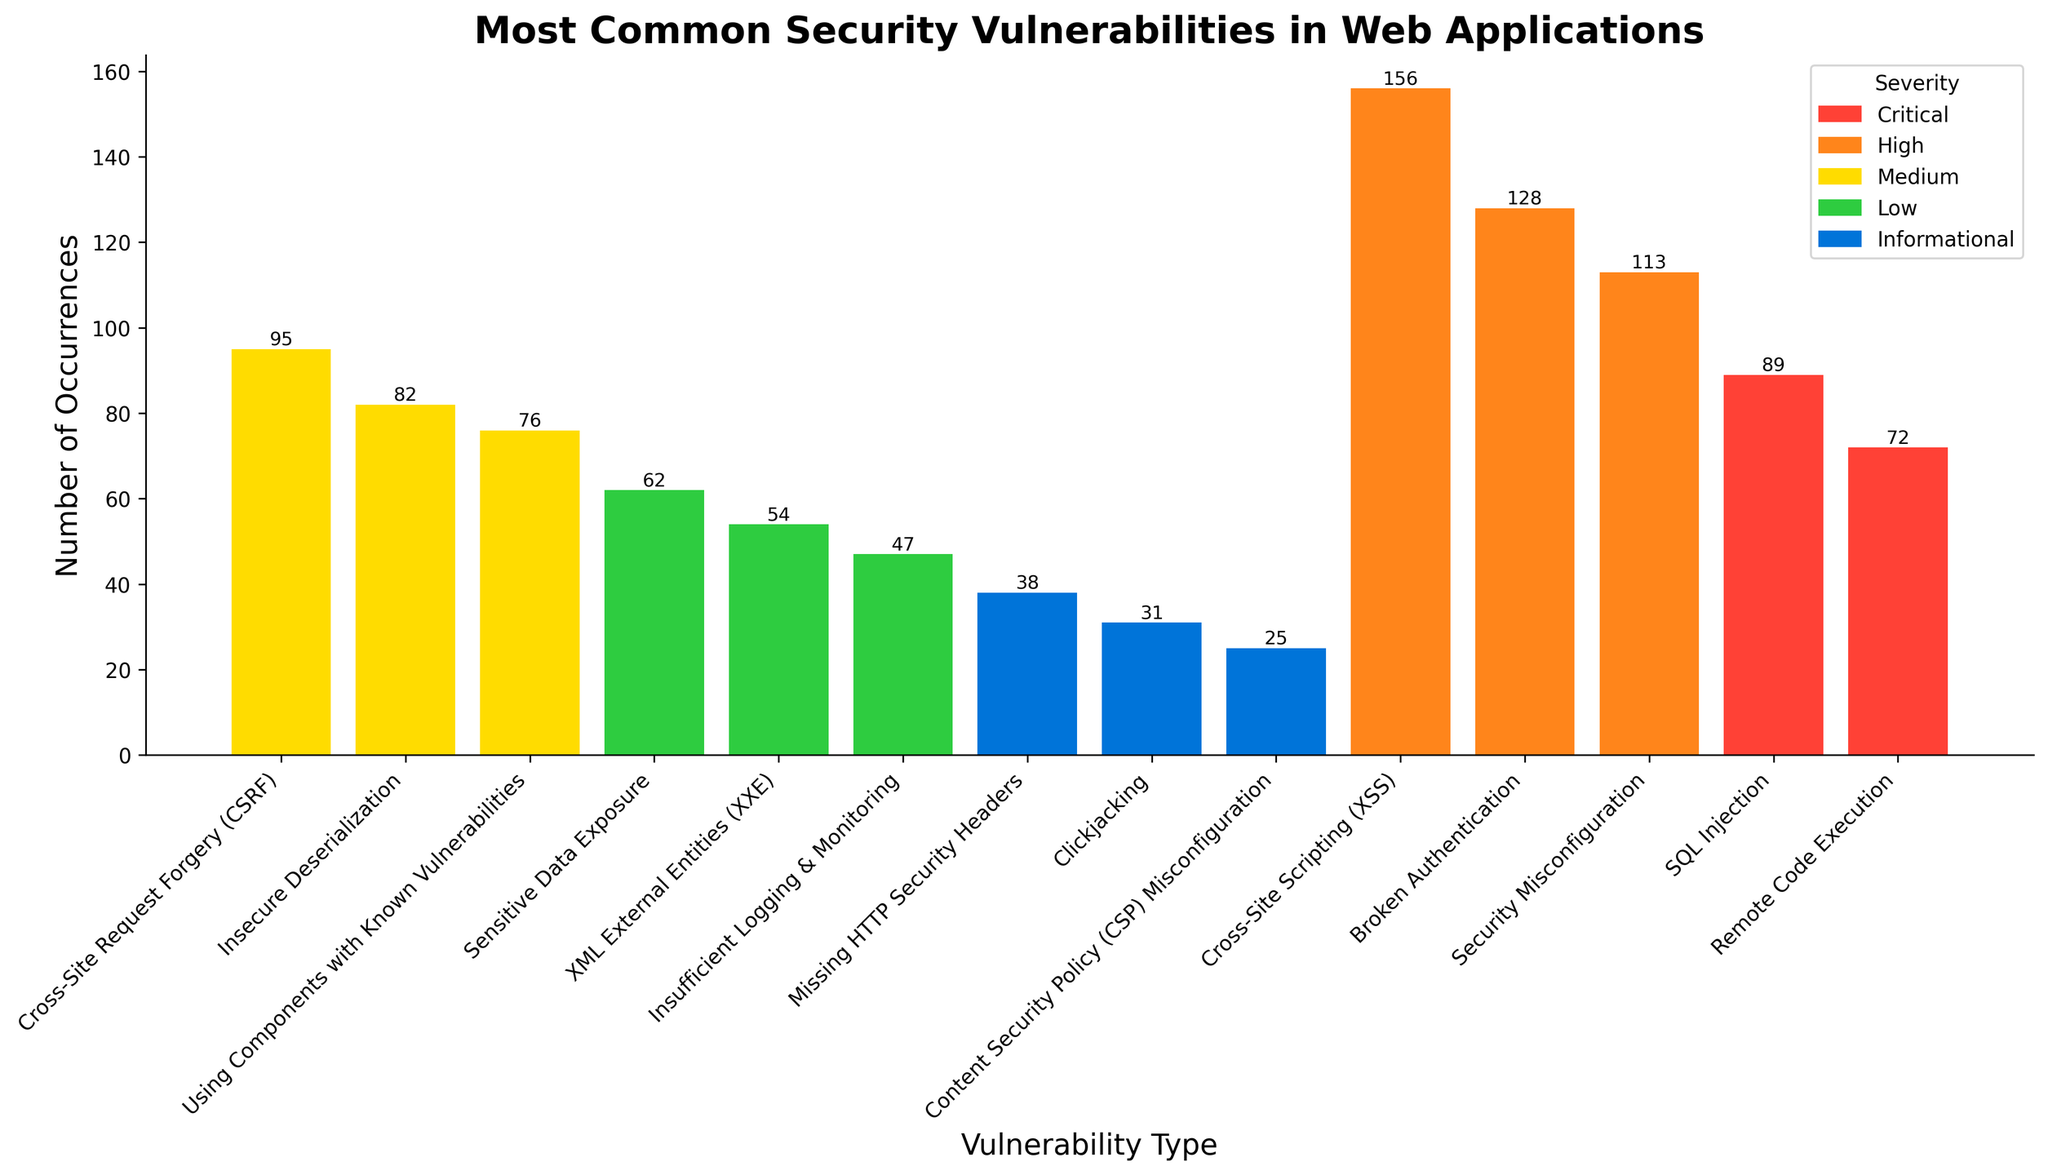Which vulnerability has the highest number of occurrences? The tallest bar in the figure corresponds to the vulnerability with the highest number of occurrences. This bar represents "Cross-Site Scripting (XSS)" with 156 occurrences.
Answer: Cross-Site Scripting (XSS) Which severity level has the fewest total occurrences? To determine the severity level with the fewest occurrences, sum the number of occurrences of vulnerabilities within each severity and compare. The "Informational" severity with 38 + 31 + 25 = 94 occurrences has the fewest.
Answer: Informational What is the combined total of occurrences for "Critical" severity vulnerabilities? Add the occurrences of all vulnerabilities listed under "Critical" severity: 89 (SQL Injection) + 72 (Remote Code Execution) = 161.
Answer: 161 Which "Low" severity vulnerability has more occurrences: "Sensitive Data Exposure" or "XML External Entities (XXE)"? Compare the heights of the bars for "Sensitive Data Exposure" and "XML External Entities (XXE)". "Sensitive Data Exposure" has 62 occurrences, while "XML External Entities (XXE)" has 54.
Answer: Sensitive Data Exposure How many more occurrences does "Cross-Site Scripting (XSS)" have compared to "Security Misconfiguration"? Subtract the number of occurrences of "Security Misconfiguration" from those of "Cross-Site Scripting (XSS)": 156 - 113 = 43.
Answer: 43 Which vulnerability under "Medium" severity has the fewest occurrences? Among the "Medium" severity vulnerabilities, "Using Components with Known Vulnerabilities" has the fewest occurrences, with 76.
Answer: Using Components with Known Vulnerabilities If you sum the occurrences for "Broken Authentication" and "Remote Code Execution", what is the total? Add the number of occurrences of "Broken Authentication" and "Remote Code Execution": 128 + 72 = 200.
Answer: 200 What's the average number of occurrences for the "High" severity vulnerabilities? Sum the occurrences for all "High" severity vulnerabilities and divide by the number of vulnerabilities: (156 + 128 + 113) / 3 = 397 / 3 ≈ 132.33.
Answer: 132.33 